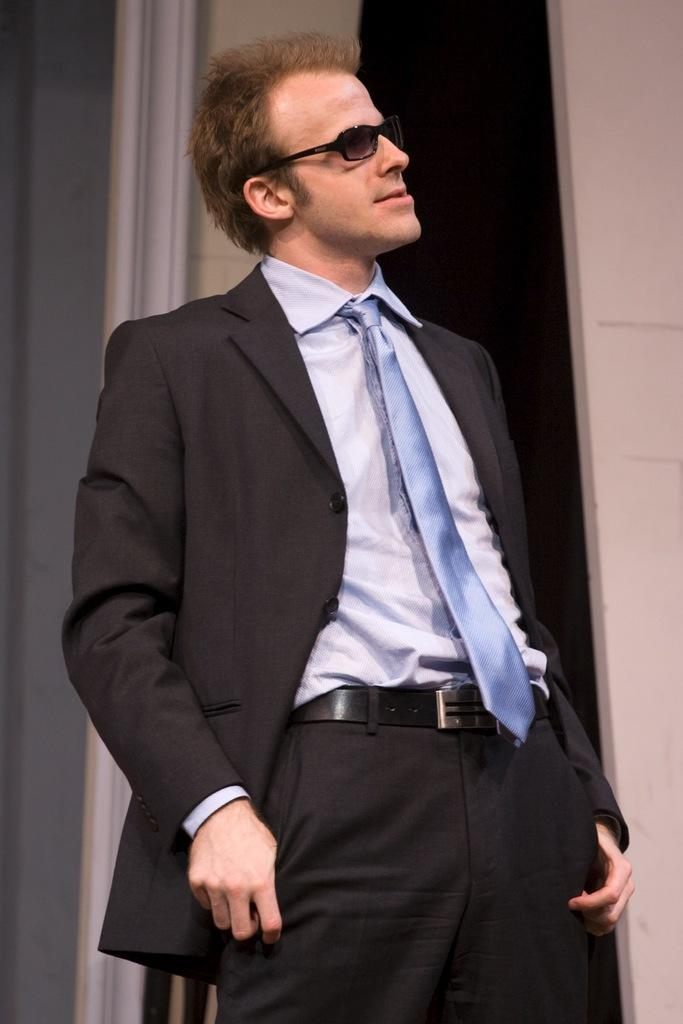What is the main subject of the image? There is a man standing in the image. What is the man wearing in the image? The man is wearing a suit and spectacles. What can be seen behind the man in the image? There is a wall behind the man. What type of soup is the man sorting in the image? There is no soup or sorting activity present in the image. Are there any police officers visible in the image? There are no police officers present in the image. 